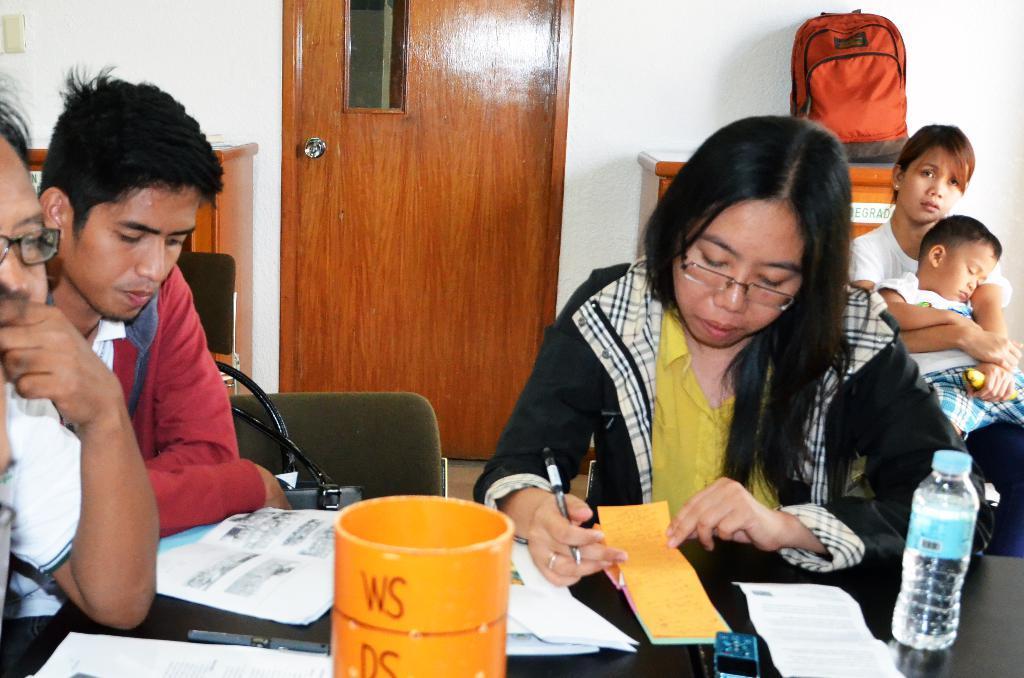Describe this image in one or two sentences. Here we can see a group of people sitting on chairs with a table in front of them and there are papers on table and a bottle of water present and the lady at the right side is writing something with a pen in her hand, behind them we can see door and a bag present 